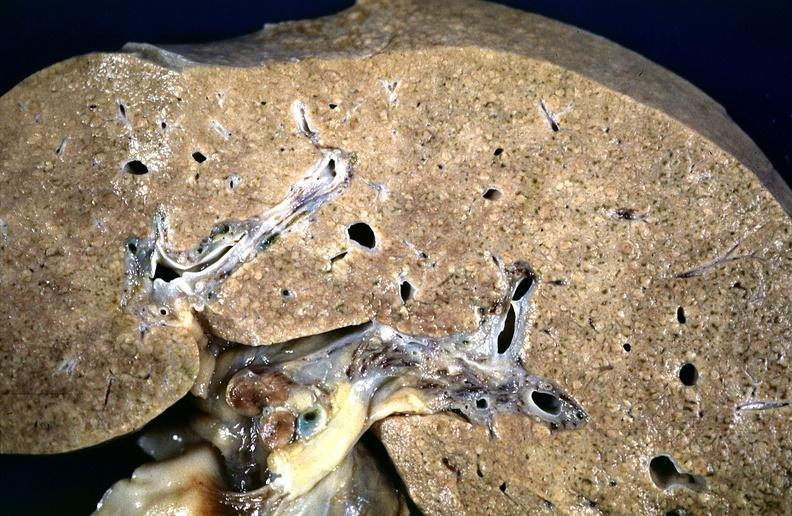s liver present?
Answer the question using a single word or phrase. Yes 